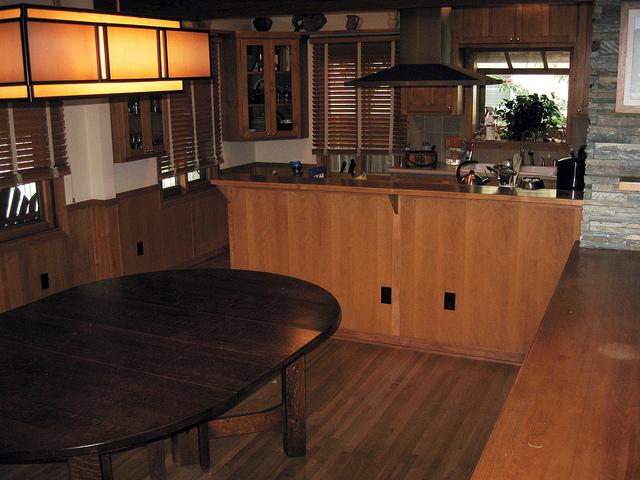Is that table made of wood?
Keep it brief. Yes. What is this area in a home primarily used for?
Answer briefly. Eating. Are there any objects on the table?
Short answer required. No. Does this look like the dining room?
Short answer required. Yes. Is this photo outdoors?
Give a very brief answer. No. Is the floor hardwood?
Answer briefly. Yes. 